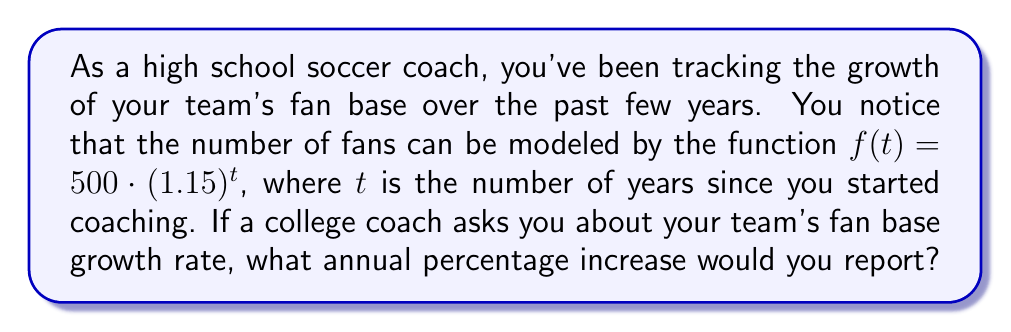Give your solution to this math problem. To find the annual percentage increase, we need to analyze the given exponential function:

1) The function is in the form $f(t) = a \cdot b^t$, where:
   $a = 500$ (initial number of fans)
   $b = 1.15$ (growth factor)

2) The growth factor $b$ represents how much the fan base multiplies each year.
   In this case, it's 1.15 times the previous year's number.

3) To convert this to a percentage increase, we subtract 1 from the growth factor and multiply by 100:

   $\text{Percentage increase} = (b - 1) \times 100\%$
   
   $= (1.15 - 1) \times 100\%$
   
   $= 0.15 \times 100\%$
   
   $= 15\%$

Therefore, the fan base is increasing by 15% annually.
Answer: 15% 